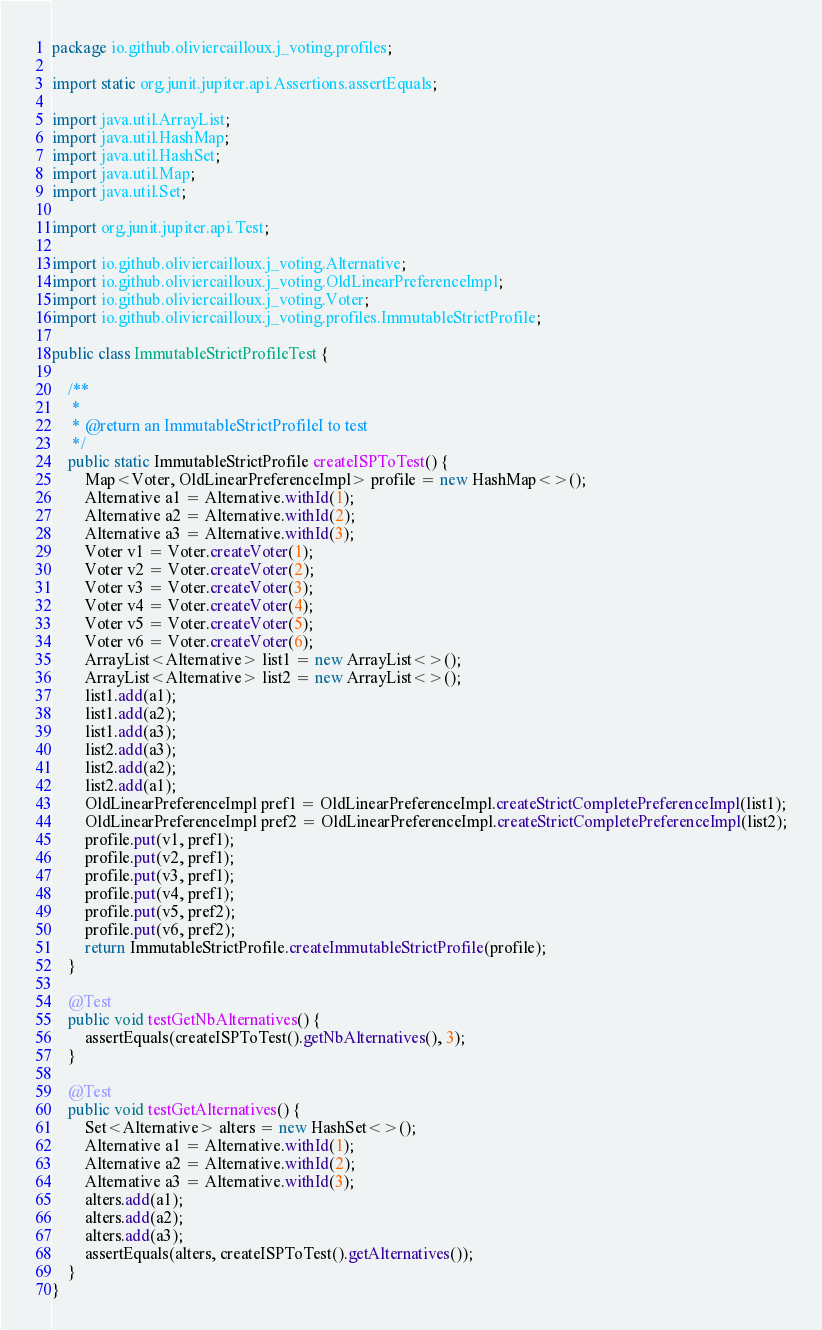Convert code to text. <code><loc_0><loc_0><loc_500><loc_500><_Java_>package io.github.oliviercailloux.j_voting.profiles;

import static org.junit.jupiter.api.Assertions.assertEquals;

import java.util.ArrayList;
import java.util.HashMap;
import java.util.HashSet;
import java.util.Map;
import java.util.Set;

import org.junit.jupiter.api.Test;

import io.github.oliviercailloux.j_voting.Alternative;
import io.github.oliviercailloux.j_voting.OldLinearPreferenceImpl;
import io.github.oliviercailloux.j_voting.Voter;
import io.github.oliviercailloux.j_voting.profiles.ImmutableStrictProfile;

public class ImmutableStrictProfileTest {

    /**
     * 
     * @return an ImmutableStrictProfileI to test
     */
    public static ImmutableStrictProfile createISPToTest() {
        Map<Voter, OldLinearPreferenceImpl> profile = new HashMap<>();
        Alternative a1 = Alternative.withId(1);
        Alternative a2 = Alternative.withId(2);
        Alternative a3 = Alternative.withId(3);
        Voter v1 = Voter.createVoter(1);
        Voter v2 = Voter.createVoter(2);
        Voter v3 = Voter.createVoter(3);
        Voter v4 = Voter.createVoter(4);
        Voter v5 = Voter.createVoter(5);
        Voter v6 = Voter.createVoter(6);
        ArrayList<Alternative> list1 = new ArrayList<>();
        ArrayList<Alternative> list2 = new ArrayList<>();
        list1.add(a1);
        list1.add(a2);
        list1.add(a3);
        list2.add(a3);
        list2.add(a2);
        list2.add(a1);
        OldLinearPreferenceImpl pref1 = OldLinearPreferenceImpl.createStrictCompletePreferenceImpl(list1);
        OldLinearPreferenceImpl pref2 = OldLinearPreferenceImpl.createStrictCompletePreferenceImpl(list2);
        profile.put(v1, pref1);
        profile.put(v2, pref1);
        profile.put(v3, pref1);
        profile.put(v4, pref1);
        profile.put(v5, pref2);
        profile.put(v6, pref2);
        return ImmutableStrictProfile.createImmutableStrictProfile(profile);
    }

    @Test
    public void testGetNbAlternatives() {
        assertEquals(createISPToTest().getNbAlternatives(), 3);
    }

    @Test
    public void testGetAlternatives() {
        Set<Alternative> alters = new HashSet<>();
        Alternative a1 = Alternative.withId(1);
        Alternative a2 = Alternative.withId(2);
        Alternative a3 = Alternative.withId(3);
        alters.add(a1);
        alters.add(a2);
        alters.add(a3);
        assertEquals(alters, createISPToTest().getAlternatives());
    }
}
</code> 